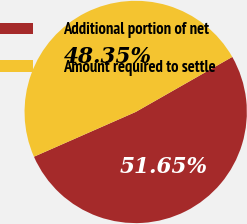Convert chart to OTSL. <chart><loc_0><loc_0><loc_500><loc_500><pie_chart><fcel>Additional portion of net<fcel>Amount required to settle<nl><fcel>51.65%<fcel>48.35%<nl></chart> 